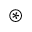<formula> <loc_0><loc_0><loc_500><loc_500>\circledast</formula> 